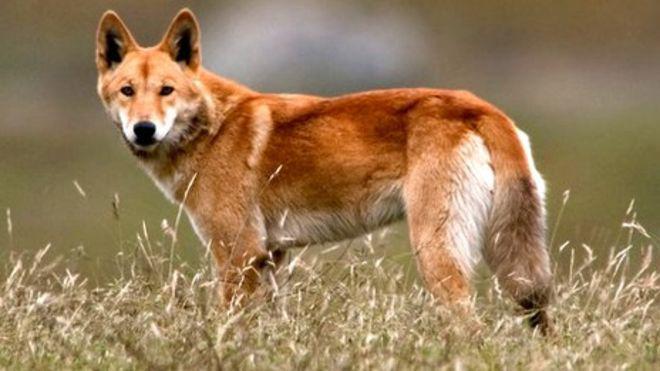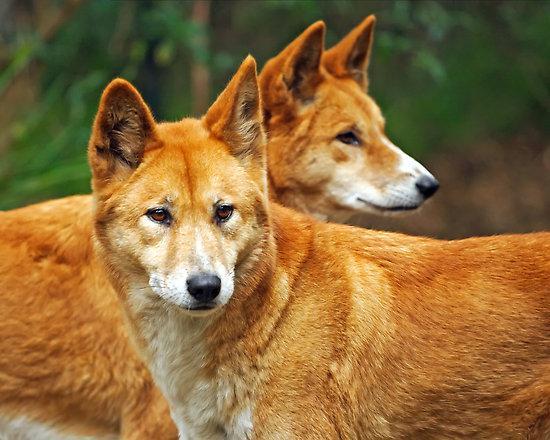The first image is the image on the left, the second image is the image on the right. Analyze the images presented: Is the assertion "The dog on the right image has its mouth wide open." valid? Answer yes or no. No. 